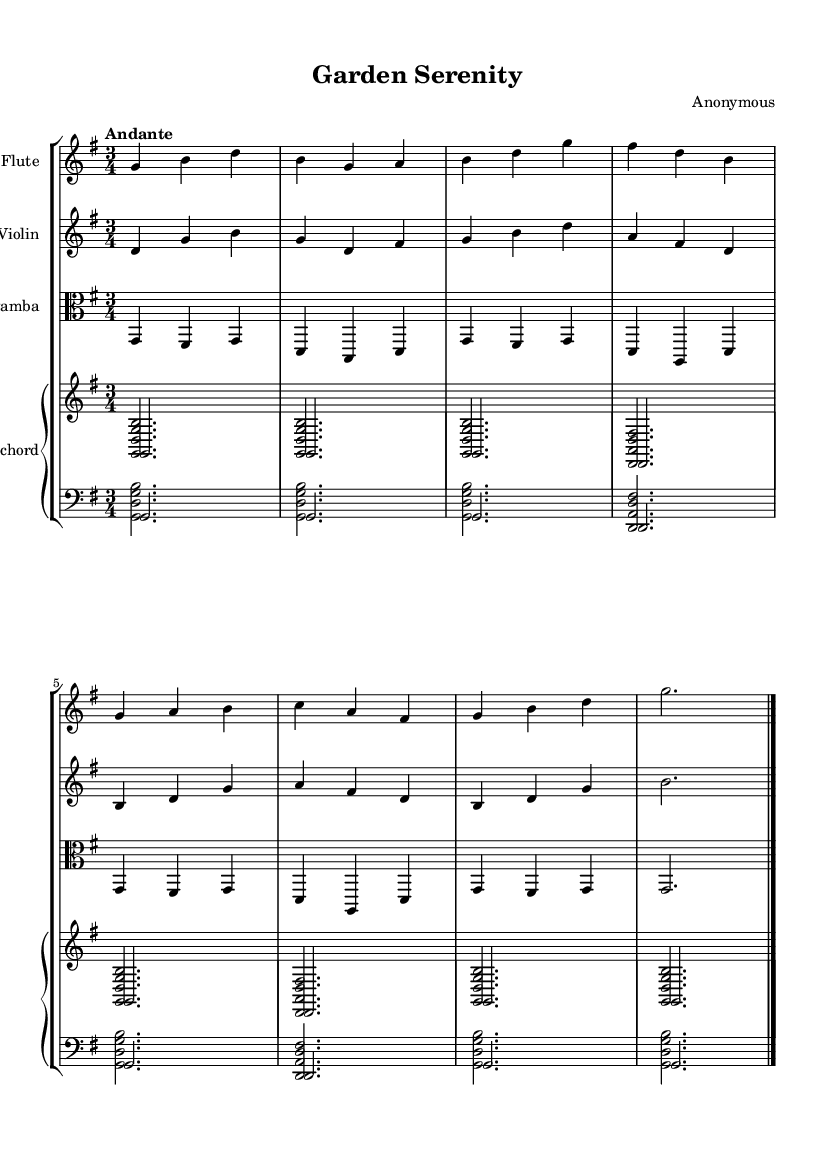What is the title of this piece? The title of the piece is found at the top of the sheet music under the header section. It reads “Garden Serenity.”
Answer: Garden Serenity What is the key signature of this music? The key signature is indicated at the beginning of the piece. It shows one sharp, indicating that the key is G major.
Answer: G major What is the time signature of this music? The time signature is noted at the beginning of the score, which reads 3/4, indicating three beats in each measure and a quarter note gets one beat.
Answer: 3/4 What is the tempo marking of this piece? The tempo marking is found directly below the time signature and indicates how fast the piece should be played. It reads "Andante," which means moderately slow.
Answer: Andante How many instruments are featured in this score? By counting the distinct instrument names displayed at the start of each staff, it can be noted that there are four instruments: Flute, Violin, Viola da gamba, and Harpsichord.
Answer: Four What is the texture of this piece? In a Baroque context, the texture can be determined by the number of independent melodies occurring simultaneously. This piece features a typical Baroque texture with interwoven melodic lines from the respective instruments, indicating a polyphonic texture.
Answer: Polyphonic What is the role of the harpsichord in this piece? In Baroque music, the harpsichord often serves as a continuo instrument. Here it provides harmonic support and rhythmic foundation while enhancing the texture.
Answer: Continuo 